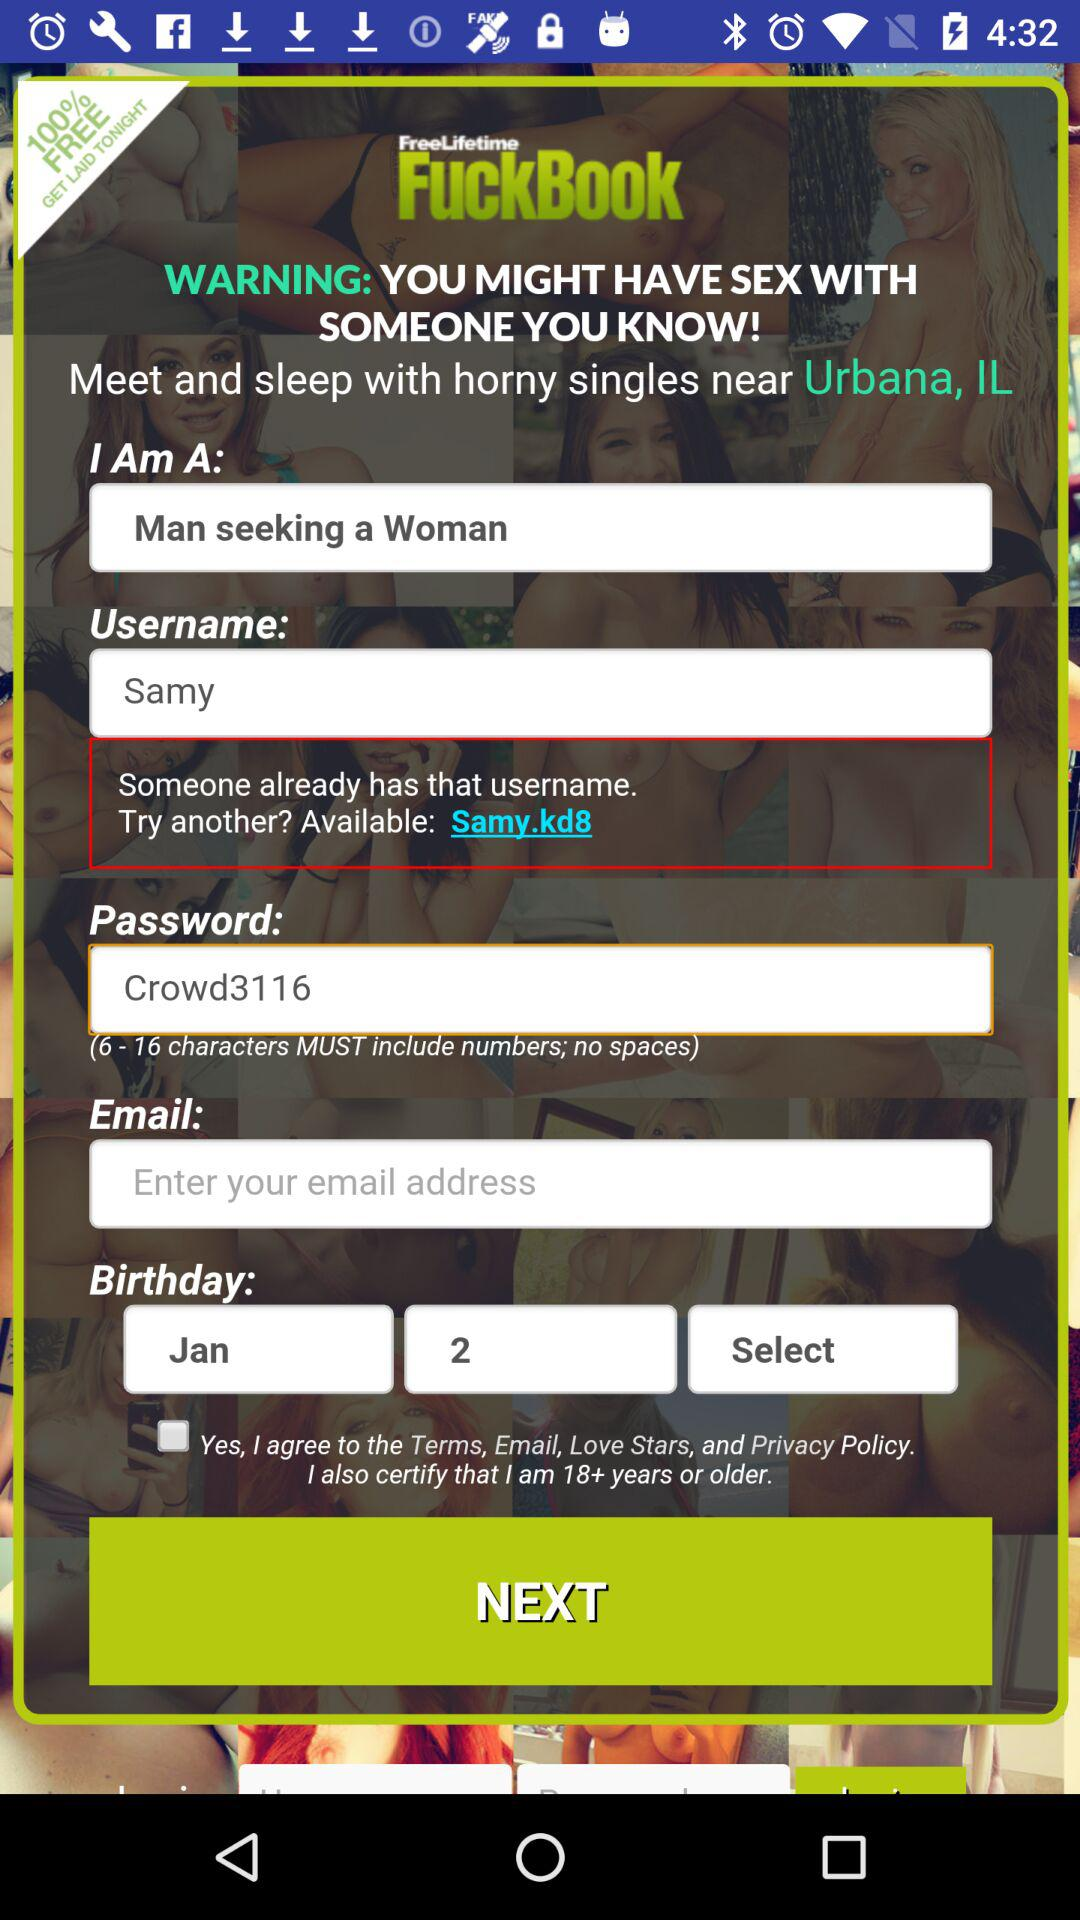What is the date of birth? The date of birth is January 2. 